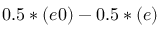<formula> <loc_0><loc_0><loc_500><loc_500>0 . 5 * ( e 0 ) - 0 . 5 * ( e )</formula> 